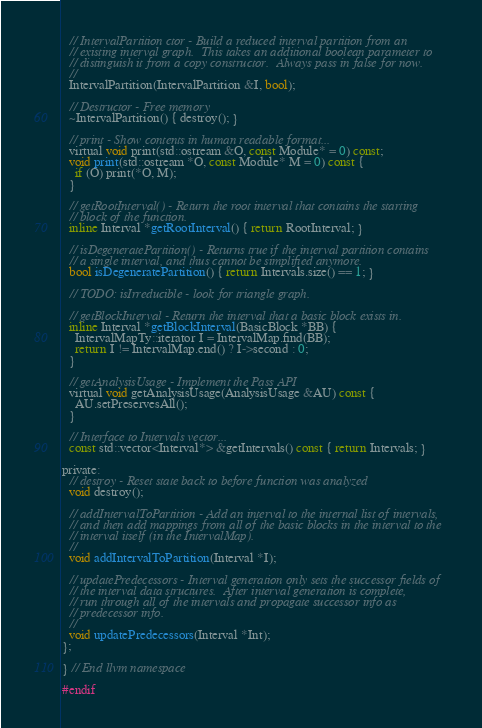Convert code to text. <code><loc_0><loc_0><loc_500><loc_500><_C_>
  // IntervalPartition ctor - Build a reduced interval partition from an
  // existing interval graph.  This takes an additional boolean parameter to
  // distinguish it from a copy constructor.  Always pass in false for now.
  //
  IntervalPartition(IntervalPartition &I, bool);

  // Destructor - Free memory
  ~IntervalPartition() { destroy(); }

  // print - Show contents in human readable format...
  virtual void print(std::ostream &O, const Module* = 0) const;
  void print(std::ostream *O, const Module* M = 0) const {
    if (O) print(*O, M);
  }

  // getRootInterval() - Return the root interval that contains the starting
  // block of the function.
  inline Interval *getRootInterval() { return RootInterval; }

  // isDegeneratePartition() - Returns true if the interval partition contains
  // a single interval, and thus cannot be simplified anymore.
  bool isDegeneratePartition() { return Intervals.size() == 1; }

  // TODO: isIrreducible - look for triangle graph.

  // getBlockInterval - Return the interval that a basic block exists in.
  inline Interval *getBlockInterval(BasicBlock *BB) {
    IntervalMapTy::iterator I = IntervalMap.find(BB);
    return I != IntervalMap.end() ? I->second : 0;
  }

  // getAnalysisUsage - Implement the Pass API
  virtual void getAnalysisUsage(AnalysisUsage &AU) const {
    AU.setPreservesAll();
  }

  // Interface to Intervals vector...
  const std::vector<Interval*> &getIntervals() const { return Intervals; }

private:
  // destroy - Reset state back to before function was analyzed
  void destroy();

  // addIntervalToPartition - Add an interval to the internal list of intervals,
  // and then add mappings from all of the basic blocks in the interval to the
  // interval itself (in the IntervalMap).
  //
  void addIntervalToPartition(Interval *I);

  // updatePredecessors - Interval generation only sets the successor fields of
  // the interval data structures.  After interval generation is complete,
  // run through all of the intervals and propagate successor info as
  // predecessor info.
  //
  void updatePredecessors(Interval *Int);
};

} // End llvm namespace

#endif
</code> 